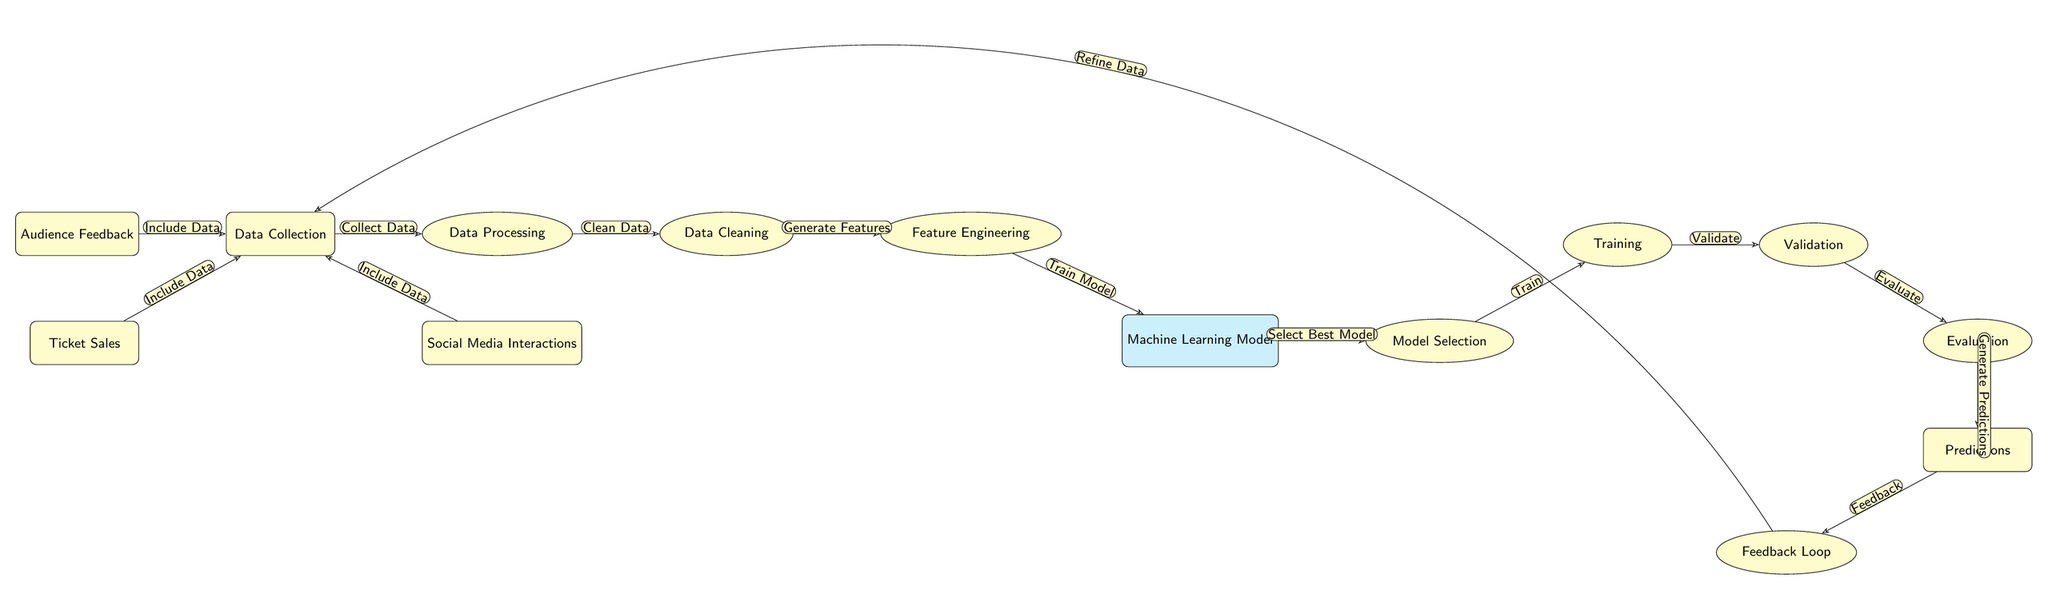What is the first step in the diagram? The diagram indicates "Data Collection" as the first step, which is the starting point for gathering information needed for audience preference predictions.
Answer: Data Collection How many data sources are listed in the diagram? The diagram shows three data sources: "Ticket Sales," "Audience Feedback," and "Social Media Interactions," indicating a total of three sources contributing to data collection.
Answer: Three What is the output of the "Evaluation" process? The "Evaluation" process produces "Predictions" as its output, signifying the result of assessing the machine learning model's performance.
Answer: Predictions Which step follows "Training"? "Validation" follows the "Training" step as represented in the diagram, indicating a subsequent stage to assess the model's accuracy after it has been trained.
Answer: Validation What type of model is indicated in the diagram? The diagram specifies a "Machine Learning Model" as the type of model that is trained and validated.
Answer: Machine Learning Model What is the purpose of the "Feedback Loop"? The "Feedback Loop" is meant for refining data by taking insights gained from the "Predictions" back to the "Data Collection" stage, suggesting it plays a critical role in continuous improvement of the model.
Answer: Refine Data What comes after "Feature Engineering"? The diagram indicates that "Machine Learning Model" comes after "Feature Engineering," which shows the flow of processes leading to the creation of a predictive model.
Answer: Machine Learning Model How do social media interactions contribute to the process? "Social Media Interactions" are included as one of the data sources that feed into "Data Collection," allowing insights from audience engagement on social platforms to inform predictions.
Answer: Include Data What is the relationship between "Data Cleaning" and "Feature Engineering"? The relationship is that "Data Cleaning" directly feeds into "Feature Engineering," meaning that after cleaning the data, features can be effectively generated for model training.
Answer: Generate Features 